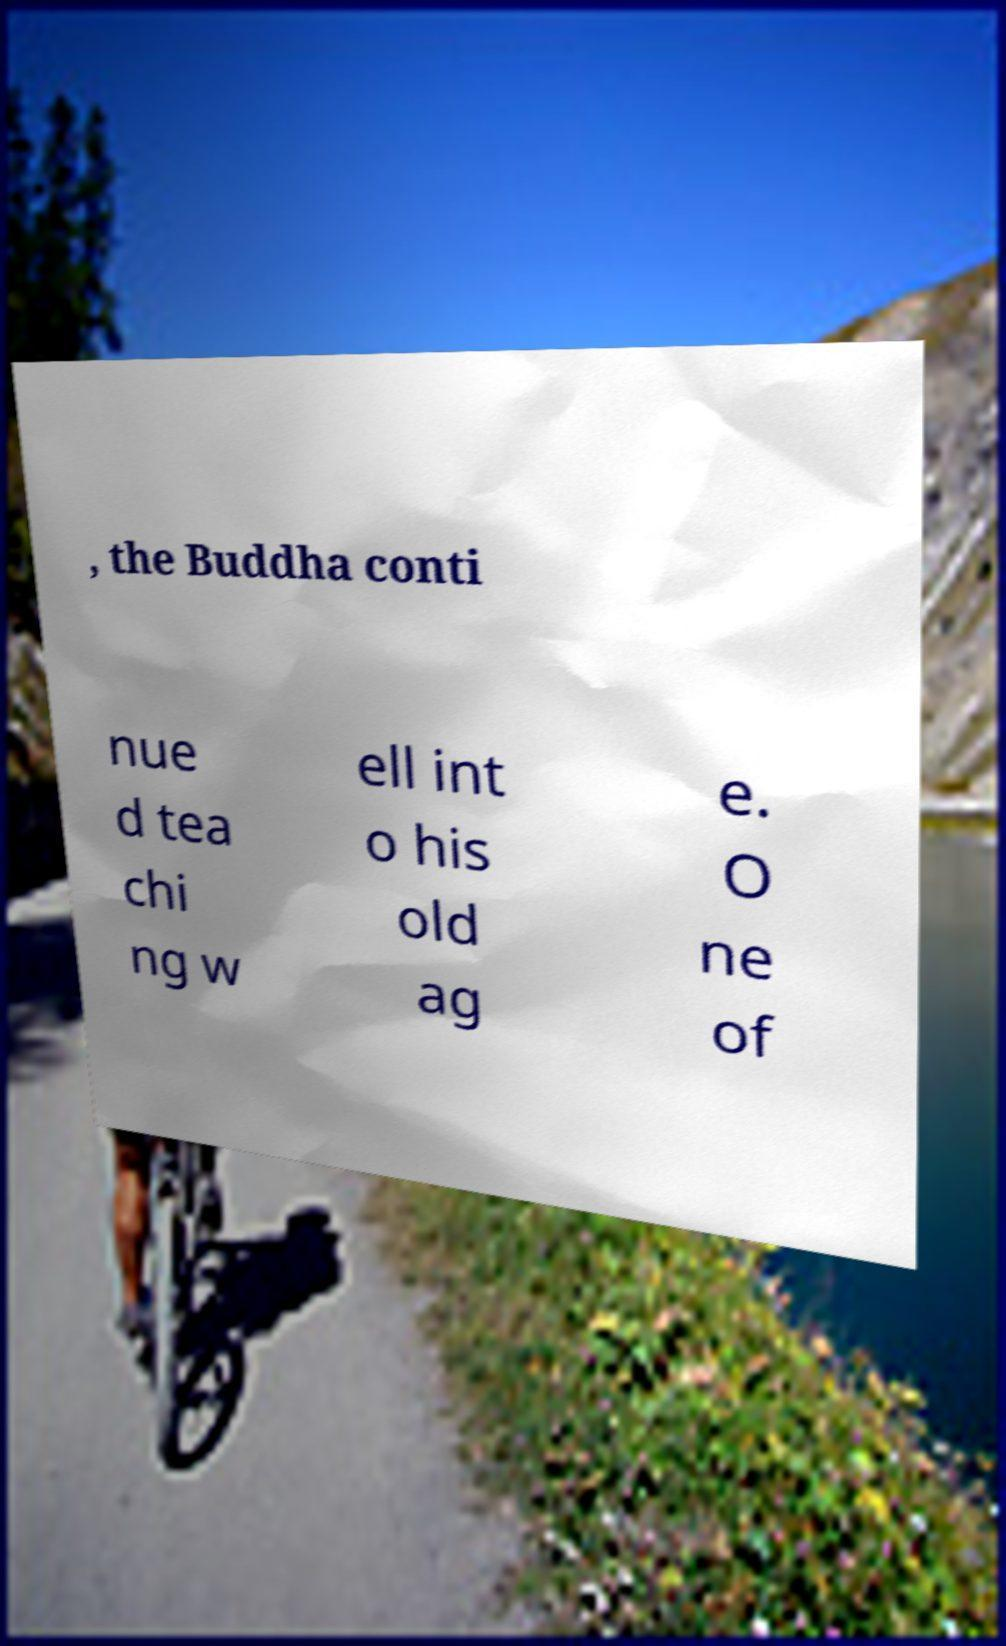Please identify and transcribe the text found in this image. , the Buddha conti nue d tea chi ng w ell int o his old ag e. O ne of 